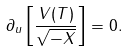Convert formula to latex. <formula><loc_0><loc_0><loc_500><loc_500>\partial _ { u } \left [ \frac { V ( T ) } { \sqrt { - X } } \right ] = 0 .</formula> 